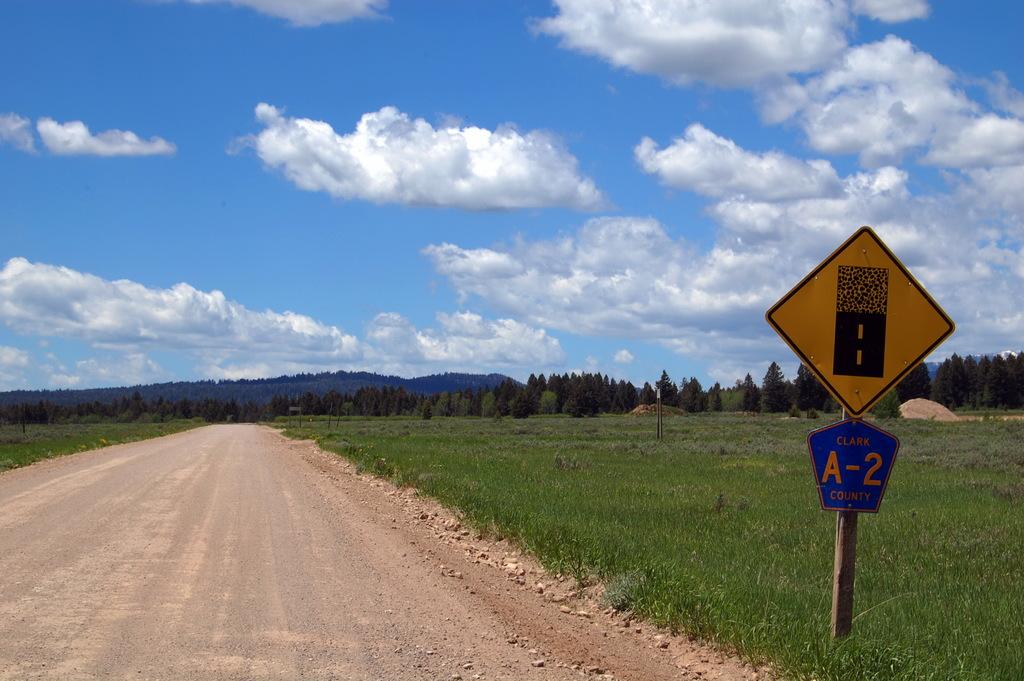What letter is written on the blue part of the sign?
Make the answer very short. A. 